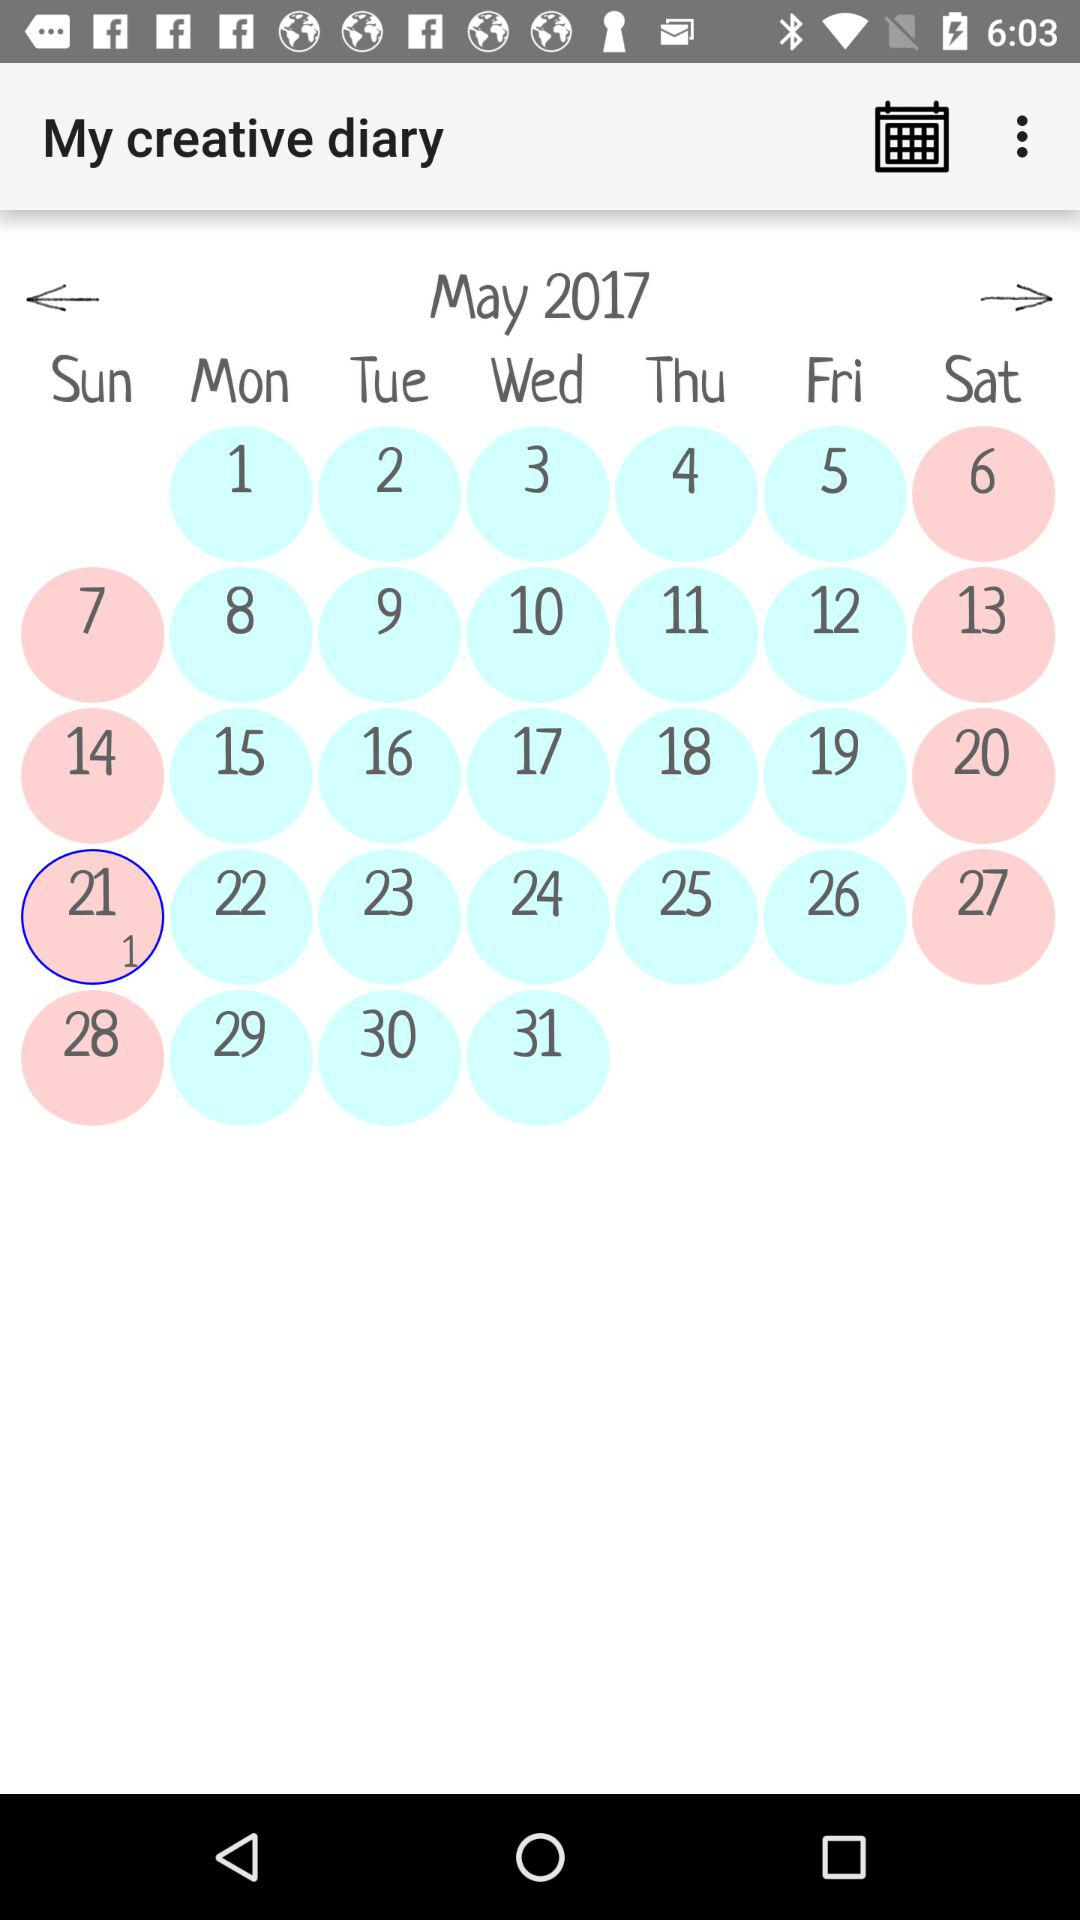What is the day on the selected date? The day is Sunday. 